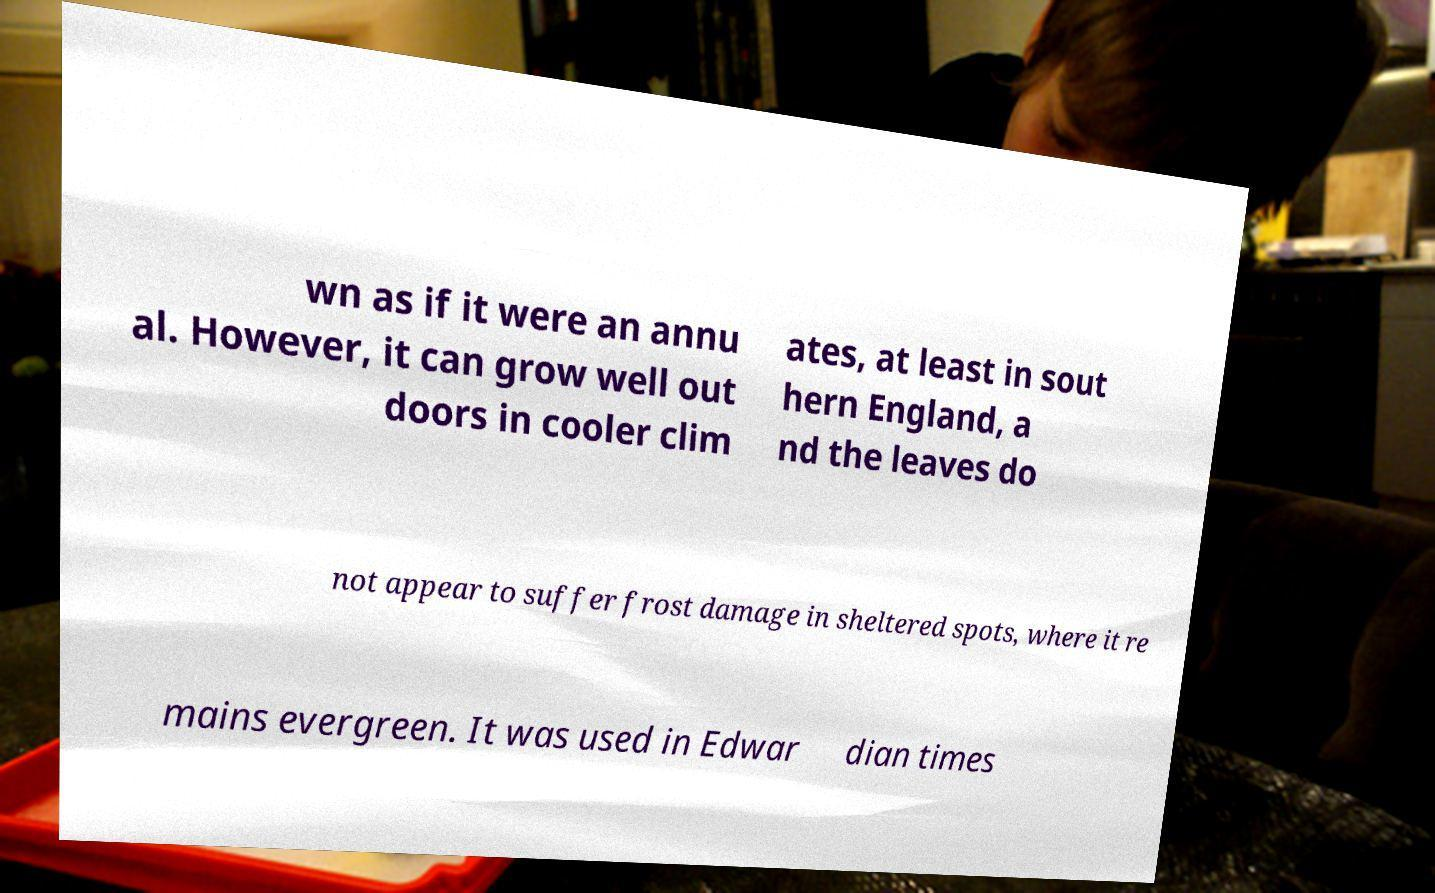Can you accurately transcribe the text from the provided image for me? wn as if it were an annu al. However, it can grow well out doors in cooler clim ates, at least in sout hern England, a nd the leaves do not appear to suffer frost damage in sheltered spots, where it re mains evergreen. It was used in Edwar dian times 